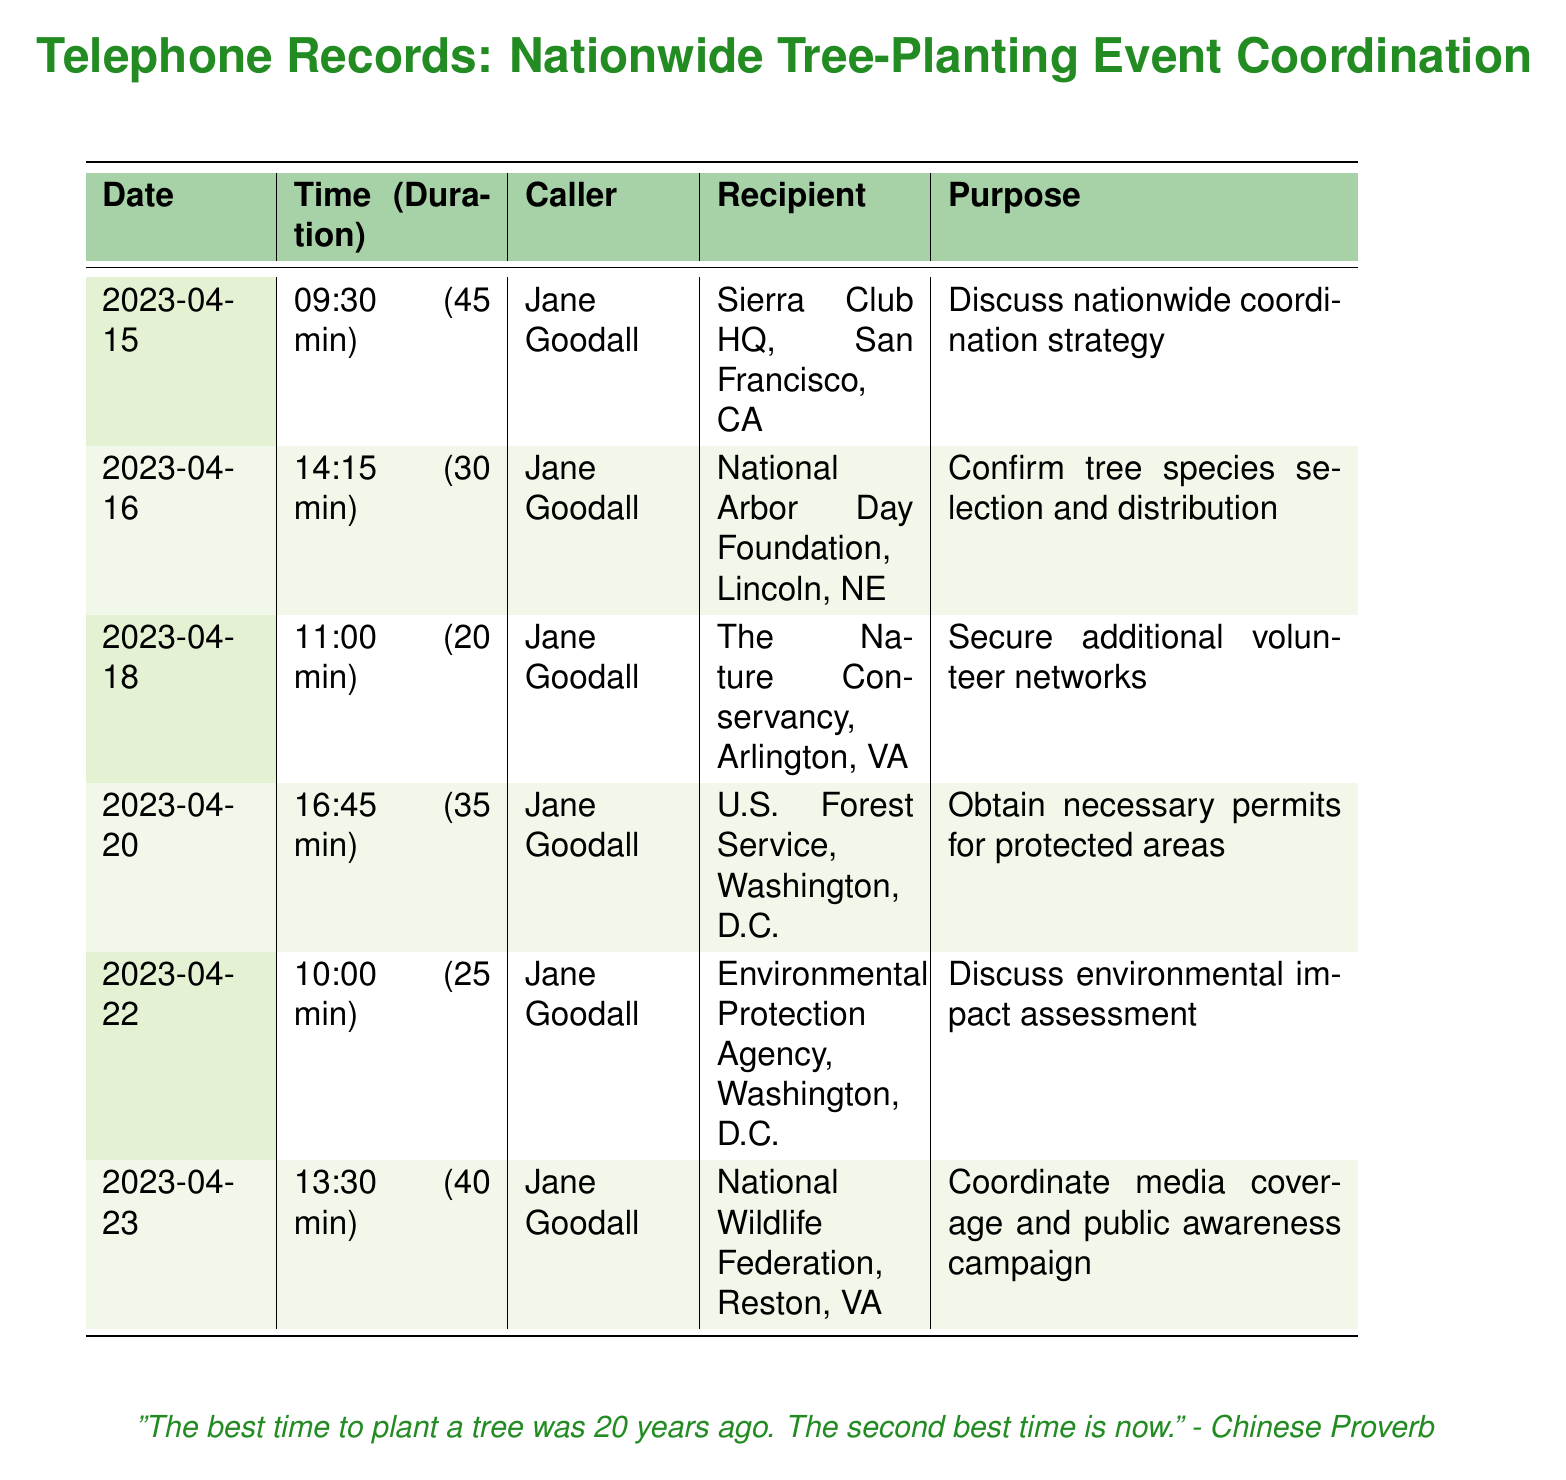what is the date of the first call? The date of the first call recorded in the document is listed in the first row of the table.
Answer: 2023-04-15 who called the Environmental Protection Agency? The table indicates the caller's name for this specific call.
Answer: Jane Goodall how long was the call with the U.S. Forest Service? The duration of the call is provided in parentheses next to the time in the corresponding row.
Answer: 35 min what was the purpose of the call to The Nature Conservancy? The purpose of each call is described in the last column of the table.
Answer: Secure additional volunteer networks how many calls were made by Jane Goodall? By counting the entries in the table, we can determine how many calls she made.
Answer: 6 which organization was contacted to confirm tree species selection? The relevant call is identified by looking at the purpose and recipient for that specific entry.
Answer: National Arbor Day Foundation what time was the call to coordinate media coverage? The time is specified in the second column of the appropriate row for that call.
Answer: 13:30 what is the total duration of all calls made? The total duration is the sum of all individual call durations found in the document.
Answer: 205 min who was the recipient of the call on April 22? The recipient is stated in the fourth column corresponding to the date given.
Answer: Environmental Protection Agency 